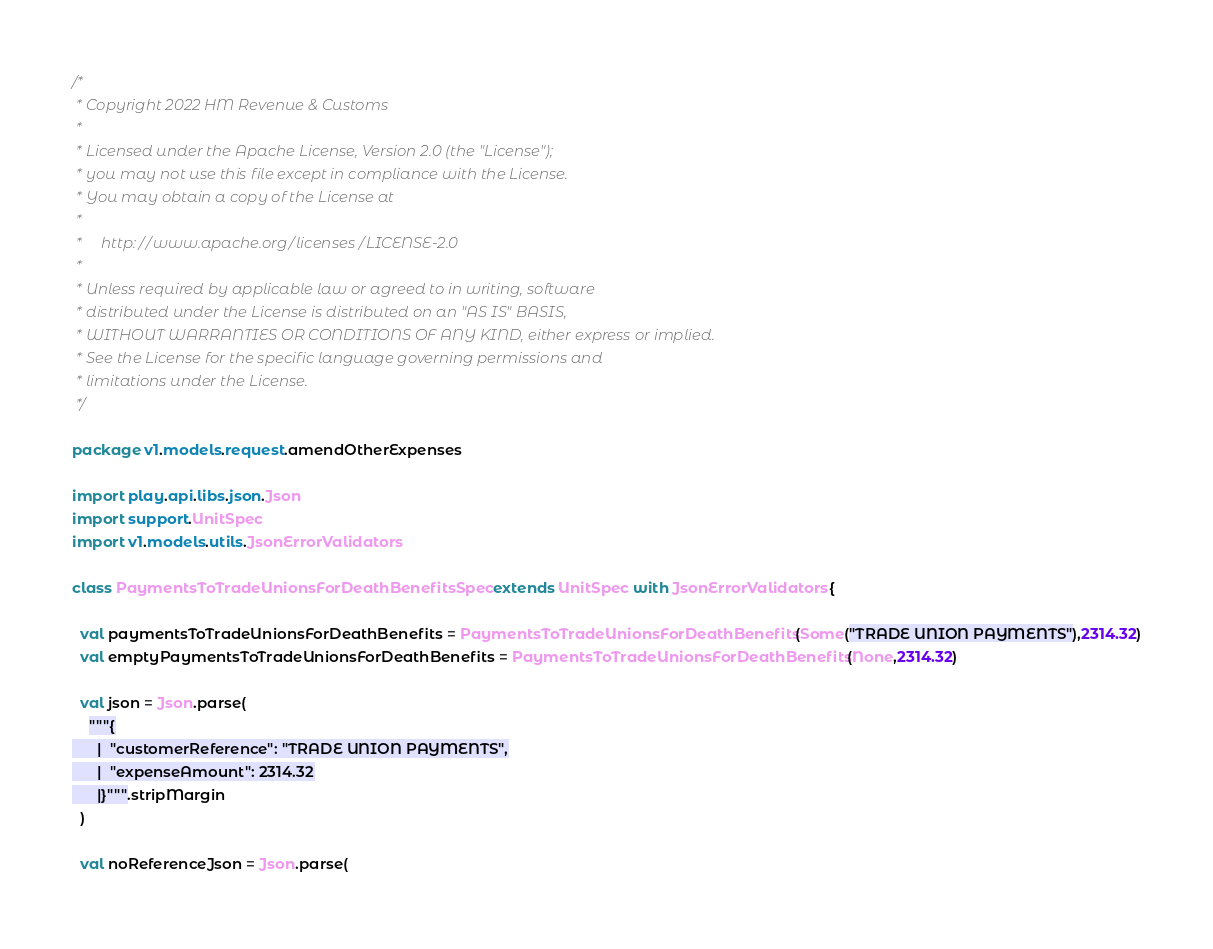Convert code to text. <code><loc_0><loc_0><loc_500><loc_500><_Scala_>/*
 * Copyright 2022 HM Revenue & Customs
 *
 * Licensed under the Apache License, Version 2.0 (the "License");
 * you may not use this file except in compliance with the License.
 * You may obtain a copy of the License at
 *
 *     http://www.apache.org/licenses/LICENSE-2.0
 *
 * Unless required by applicable law or agreed to in writing, software
 * distributed under the License is distributed on an "AS IS" BASIS,
 * WITHOUT WARRANTIES OR CONDITIONS OF ANY KIND, either express or implied.
 * See the License for the specific language governing permissions and
 * limitations under the License.
 */

package v1.models.request.amendOtherExpenses

import play.api.libs.json.Json
import support.UnitSpec
import v1.models.utils.JsonErrorValidators

class PaymentsToTradeUnionsForDeathBenefitsSpec extends UnitSpec with JsonErrorValidators {

  val paymentsToTradeUnionsForDeathBenefits = PaymentsToTradeUnionsForDeathBenefits(Some("TRADE UNION PAYMENTS"),2314.32)
  val emptyPaymentsToTradeUnionsForDeathBenefits = PaymentsToTradeUnionsForDeathBenefits(None,2314.32)

  val json = Json.parse(
    """{
      |  "customerReference": "TRADE UNION PAYMENTS",
      |  "expenseAmount": 2314.32
      |}""".stripMargin
  )

  val noReferenceJson = Json.parse(</code> 